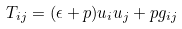Convert formula to latex. <formula><loc_0><loc_0><loc_500><loc_500>T _ { i j } = ( \epsilon + p ) u _ { i } u _ { j } + p g _ { i j }</formula> 